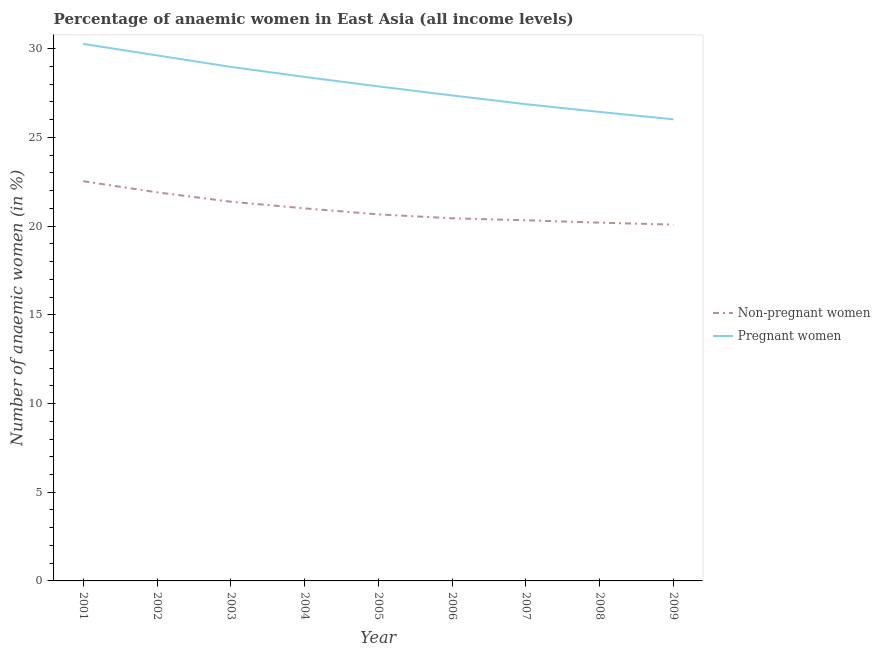Is the number of lines equal to the number of legend labels?
Give a very brief answer. Yes. What is the percentage of non-pregnant anaemic women in 2009?
Your answer should be compact. 20.09. Across all years, what is the maximum percentage of pregnant anaemic women?
Your answer should be compact. 30.27. Across all years, what is the minimum percentage of pregnant anaemic women?
Your answer should be compact. 26.02. What is the total percentage of pregnant anaemic women in the graph?
Your answer should be very brief. 251.89. What is the difference between the percentage of non-pregnant anaemic women in 2001 and that in 2002?
Your answer should be compact. 0.63. What is the difference between the percentage of non-pregnant anaemic women in 2003 and the percentage of pregnant anaemic women in 2006?
Make the answer very short. -5.99. What is the average percentage of non-pregnant anaemic women per year?
Offer a very short reply. 20.95. In the year 2009, what is the difference between the percentage of pregnant anaemic women and percentage of non-pregnant anaemic women?
Provide a succinct answer. 5.94. What is the ratio of the percentage of pregnant anaemic women in 2002 to that in 2007?
Give a very brief answer. 1.1. Is the difference between the percentage of pregnant anaemic women in 2002 and 2008 greater than the difference between the percentage of non-pregnant anaemic women in 2002 and 2008?
Your answer should be very brief. Yes. What is the difference between the highest and the second highest percentage of pregnant anaemic women?
Offer a terse response. 0.65. What is the difference between the highest and the lowest percentage of non-pregnant anaemic women?
Keep it short and to the point. 2.45. In how many years, is the percentage of non-pregnant anaemic women greater than the average percentage of non-pregnant anaemic women taken over all years?
Give a very brief answer. 4. Is the percentage of pregnant anaemic women strictly less than the percentage of non-pregnant anaemic women over the years?
Provide a succinct answer. No. Does the graph contain any zero values?
Your response must be concise. No. Does the graph contain grids?
Offer a terse response. No. Where does the legend appear in the graph?
Your answer should be very brief. Center right. How many legend labels are there?
Keep it short and to the point. 2. How are the legend labels stacked?
Offer a terse response. Vertical. What is the title of the graph?
Ensure brevity in your answer.  Percentage of anaemic women in East Asia (all income levels). What is the label or title of the X-axis?
Provide a succinct answer. Year. What is the label or title of the Y-axis?
Offer a terse response. Number of anaemic women (in %). What is the Number of anaemic women (in %) of Non-pregnant women in 2001?
Your answer should be very brief. 22.53. What is the Number of anaemic women (in %) of Pregnant women in 2001?
Ensure brevity in your answer.  30.27. What is the Number of anaemic women (in %) of Non-pregnant women in 2002?
Your answer should be compact. 21.91. What is the Number of anaemic women (in %) of Pregnant women in 2002?
Make the answer very short. 29.63. What is the Number of anaemic women (in %) in Non-pregnant women in 2003?
Your response must be concise. 21.38. What is the Number of anaemic women (in %) in Pregnant women in 2003?
Offer a very short reply. 28.98. What is the Number of anaemic women (in %) of Non-pregnant women in 2004?
Keep it short and to the point. 21. What is the Number of anaemic women (in %) in Pregnant women in 2004?
Offer a terse response. 28.41. What is the Number of anaemic women (in %) in Non-pregnant women in 2005?
Provide a succinct answer. 20.66. What is the Number of anaemic women (in %) of Pregnant women in 2005?
Offer a very short reply. 27.88. What is the Number of anaemic women (in %) in Non-pregnant women in 2006?
Make the answer very short. 20.44. What is the Number of anaemic women (in %) in Pregnant women in 2006?
Provide a short and direct response. 27.37. What is the Number of anaemic women (in %) of Non-pregnant women in 2007?
Provide a succinct answer. 20.33. What is the Number of anaemic women (in %) of Pregnant women in 2007?
Ensure brevity in your answer.  26.88. What is the Number of anaemic women (in %) of Non-pregnant women in 2008?
Your answer should be very brief. 20.2. What is the Number of anaemic women (in %) of Pregnant women in 2008?
Ensure brevity in your answer.  26.44. What is the Number of anaemic women (in %) in Non-pregnant women in 2009?
Make the answer very short. 20.09. What is the Number of anaemic women (in %) in Pregnant women in 2009?
Offer a very short reply. 26.02. Across all years, what is the maximum Number of anaemic women (in %) in Non-pregnant women?
Make the answer very short. 22.53. Across all years, what is the maximum Number of anaemic women (in %) in Pregnant women?
Offer a very short reply. 30.27. Across all years, what is the minimum Number of anaemic women (in %) in Non-pregnant women?
Provide a short and direct response. 20.09. Across all years, what is the minimum Number of anaemic women (in %) in Pregnant women?
Your answer should be compact. 26.02. What is the total Number of anaemic women (in %) in Non-pregnant women in the graph?
Your response must be concise. 188.55. What is the total Number of anaemic women (in %) in Pregnant women in the graph?
Your answer should be very brief. 251.89. What is the difference between the Number of anaemic women (in %) in Non-pregnant women in 2001 and that in 2002?
Your answer should be very brief. 0.63. What is the difference between the Number of anaemic women (in %) in Pregnant women in 2001 and that in 2002?
Your response must be concise. 0.65. What is the difference between the Number of anaemic women (in %) of Non-pregnant women in 2001 and that in 2003?
Make the answer very short. 1.15. What is the difference between the Number of anaemic women (in %) of Pregnant women in 2001 and that in 2003?
Make the answer very short. 1.29. What is the difference between the Number of anaemic women (in %) in Non-pregnant women in 2001 and that in 2004?
Give a very brief answer. 1.53. What is the difference between the Number of anaemic women (in %) of Pregnant women in 2001 and that in 2004?
Provide a succinct answer. 1.86. What is the difference between the Number of anaemic women (in %) of Non-pregnant women in 2001 and that in 2005?
Give a very brief answer. 1.87. What is the difference between the Number of anaemic women (in %) of Pregnant women in 2001 and that in 2005?
Provide a short and direct response. 2.4. What is the difference between the Number of anaemic women (in %) of Non-pregnant women in 2001 and that in 2006?
Your answer should be compact. 2.09. What is the difference between the Number of anaemic women (in %) in Pregnant women in 2001 and that in 2006?
Ensure brevity in your answer.  2.9. What is the difference between the Number of anaemic women (in %) of Non-pregnant women in 2001 and that in 2007?
Your answer should be compact. 2.2. What is the difference between the Number of anaemic women (in %) of Pregnant women in 2001 and that in 2007?
Make the answer very short. 3.4. What is the difference between the Number of anaemic women (in %) of Non-pregnant women in 2001 and that in 2008?
Offer a terse response. 2.34. What is the difference between the Number of anaemic women (in %) of Pregnant women in 2001 and that in 2008?
Your answer should be very brief. 3.83. What is the difference between the Number of anaemic women (in %) of Non-pregnant women in 2001 and that in 2009?
Provide a succinct answer. 2.45. What is the difference between the Number of anaemic women (in %) in Pregnant women in 2001 and that in 2009?
Offer a very short reply. 4.25. What is the difference between the Number of anaemic women (in %) of Non-pregnant women in 2002 and that in 2003?
Make the answer very short. 0.53. What is the difference between the Number of anaemic women (in %) in Pregnant women in 2002 and that in 2003?
Ensure brevity in your answer.  0.65. What is the difference between the Number of anaemic women (in %) of Non-pregnant women in 2002 and that in 2004?
Your answer should be very brief. 0.9. What is the difference between the Number of anaemic women (in %) in Pregnant women in 2002 and that in 2004?
Provide a short and direct response. 1.21. What is the difference between the Number of anaemic women (in %) in Non-pregnant women in 2002 and that in 2005?
Ensure brevity in your answer.  1.24. What is the difference between the Number of anaemic women (in %) of Pregnant women in 2002 and that in 2005?
Offer a terse response. 1.75. What is the difference between the Number of anaemic women (in %) of Non-pregnant women in 2002 and that in 2006?
Provide a succinct answer. 1.46. What is the difference between the Number of anaemic women (in %) of Pregnant women in 2002 and that in 2006?
Make the answer very short. 2.26. What is the difference between the Number of anaemic women (in %) of Non-pregnant women in 2002 and that in 2007?
Provide a short and direct response. 1.58. What is the difference between the Number of anaemic women (in %) in Pregnant women in 2002 and that in 2007?
Give a very brief answer. 2.75. What is the difference between the Number of anaemic women (in %) in Non-pregnant women in 2002 and that in 2008?
Your answer should be compact. 1.71. What is the difference between the Number of anaemic women (in %) of Pregnant women in 2002 and that in 2008?
Keep it short and to the point. 3.19. What is the difference between the Number of anaemic women (in %) in Non-pregnant women in 2002 and that in 2009?
Provide a succinct answer. 1.82. What is the difference between the Number of anaemic women (in %) of Pregnant women in 2002 and that in 2009?
Make the answer very short. 3.6. What is the difference between the Number of anaemic women (in %) of Non-pregnant women in 2003 and that in 2004?
Your response must be concise. 0.37. What is the difference between the Number of anaemic women (in %) in Pregnant women in 2003 and that in 2004?
Ensure brevity in your answer.  0.57. What is the difference between the Number of anaemic women (in %) in Non-pregnant women in 2003 and that in 2005?
Make the answer very short. 0.72. What is the difference between the Number of anaemic women (in %) of Pregnant women in 2003 and that in 2005?
Ensure brevity in your answer.  1.1. What is the difference between the Number of anaemic women (in %) of Non-pregnant women in 2003 and that in 2006?
Ensure brevity in your answer.  0.94. What is the difference between the Number of anaemic women (in %) of Pregnant women in 2003 and that in 2006?
Make the answer very short. 1.61. What is the difference between the Number of anaemic women (in %) in Non-pregnant women in 2003 and that in 2007?
Ensure brevity in your answer.  1.05. What is the difference between the Number of anaemic women (in %) in Pregnant women in 2003 and that in 2007?
Give a very brief answer. 2.1. What is the difference between the Number of anaemic women (in %) of Non-pregnant women in 2003 and that in 2008?
Your answer should be compact. 1.18. What is the difference between the Number of anaemic women (in %) in Pregnant women in 2003 and that in 2008?
Ensure brevity in your answer.  2.54. What is the difference between the Number of anaemic women (in %) of Non-pregnant women in 2003 and that in 2009?
Ensure brevity in your answer.  1.29. What is the difference between the Number of anaemic women (in %) in Pregnant women in 2003 and that in 2009?
Offer a very short reply. 2.96. What is the difference between the Number of anaemic women (in %) in Non-pregnant women in 2004 and that in 2005?
Provide a succinct answer. 0.34. What is the difference between the Number of anaemic women (in %) of Pregnant women in 2004 and that in 2005?
Your answer should be compact. 0.53. What is the difference between the Number of anaemic women (in %) in Non-pregnant women in 2004 and that in 2006?
Your response must be concise. 0.56. What is the difference between the Number of anaemic women (in %) of Pregnant women in 2004 and that in 2006?
Your answer should be very brief. 1.04. What is the difference between the Number of anaemic women (in %) of Non-pregnant women in 2004 and that in 2007?
Your answer should be very brief. 0.67. What is the difference between the Number of anaemic women (in %) of Pregnant women in 2004 and that in 2007?
Provide a short and direct response. 1.54. What is the difference between the Number of anaemic women (in %) in Non-pregnant women in 2004 and that in 2008?
Your response must be concise. 0.81. What is the difference between the Number of anaemic women (in %) of Pregnant women in 2004 and that in 2008?
Offer a very short reply. 1.97. What is the difference between the Number of anaemic women (in %) in Non-pregnant women in 2004 and that in 2009?
Your answer should be compact. 0.92. What is the difference between the Number of anaemic women (in %) in Pregnant women in 2004 and that in 2009?
Keep it short and to the point. 2.39. What is the difference between the Number of anaemic women (in %) of Non-pregnant women in 2005 and that in 2006?
Keep it short and to the point. 0.22. What is the difference between the Number of anaemic women (in %) of Pregnant women in 2005 and that in 2006?
Make the answer very short. 0.51. What is the difference between the Number of anaemic women (in %) of Non-pregnant women in 2005 and that in 2007?
Give a very brief answer. 0.33. What is the difference between the Number of anaemic women (in %) in Pregnant women in 2005 and that in 2007?
Your answer should be very brief. 1. What is the difference between the Number of anaemic women (in %) in Non-pregnant women in 2005 and that in 2008?
Make the answer very short. 0.47. What is the difference between the Number of anaemic women (in %) in Pregnant women in 2005 and that in 2008?
Provide a short and direct response. 1.44. What is the difference between the Number of anaemic women (in %) in Non-pregnant women in 2005 and that in 2009?
Keep it short and to the point. 0.58. What is the difference between the Number of anaemic women (in %) of Pregnant women in 2005 and that in 2009?
Provide a short and direct response. 1.86. What is the difference between the Number of anaemic women (in %) of Non-pregnant women in 2006 and that in 2007?
Your response must be concise. 0.11. What is the difference between the Number of anaemic women (in %) in Pregnant women in 2006 and that in 2007?
Keep it short and to the point. 0.49. What is the difference between the Number of anaemic women (in %) in Non-pregnant women in 2006 and that in 2008?
Offer a terse response. 0.25. What is the difference between the Number of anaemic women (in %) in Pregnant women in 2006 and that in 2008?
Your answer should be compact. 0.93. What is the difference between the Number of anaemic women (in %) of Non-pregnant women in 2006 and that in 2009?
Provide a succinct answer. 0.36. What is the difference between the Number of anaemic women (in %) of Pregnant women in 2006 and that in 2009?
Your response must be concise. 1.35. What is the difference between the Number of anaemic women (in %) of Non-pregnant women in 2007 and that in 2008?
Your response must be concise. 0.13. What is the difference between the Number of anaemic women (in %) of Pregnant women in 2007 and that in 2008?
Provide a short and direct response. 0.44. What is the difference between the Number of anaemic women (in %) of Non-pregnant women in 2007 and that in 2009?
Give a very brief answer. 0.24. What is the difference between the Number of anaemic women (in %) of Pregnant women in 2007 and that in 2009?
Your answer should be very brief. 0.85. What is the difference between the Number of anaemic women (in %) of Non-pregnant women in 2008 and that in 2009?
Offer a terse response. 0.11. What is the difference between the Number of anaemic women (in %) of Pregnant women in 2008 and that in 2009?
Offer a very short reply. 0.42. What is the difference between the Number of anaemic women (in %) in Non-pregnant women in 2001 and the Number of anaemic women (in %) in Pregnant women in 2002?
Ensure brevity in your answer.  -7.09. What is the difference between the Number of anaemic women (in %) of Non-pregnant women in 2001 and the Number of anaemic women (in %) of Pregnant women in 2003?
Your response must be concise. -6.45. What is the difference between the Number of anaemic women (in %) in Non-pregnant women in 2001 and the Number of anaemic women (in %) in Pregnant women in 2004?
Provide a short and direct response. -5.88. What is the difference between the Number of anaemic women (in %) in Non-pregnant women in 2001 and the Number of anaemic women (in %) in Pregnant women in 2005?
Give a very brief answer. -5.35. What is the difference between the Number of anaemic women (in %) of Non-pregnant women in 2001 and the Number of anaemic women (in %) of Pregnant women in 2006?
Your answer should be compact. -4.84. What is the difference between the Number of anaemic women (in %) of Non-pregnant women in 2001 and the Number of anaemic women (in %) of Pregnant women in 2007?
Offer a very short reply. -4.34. What is the difference between the Number of anaemic women (in %) in Non-pregnant women in 2001 and the Number of anaemic women (in %) in Pregnant women in 2008?
Your answer should be compact. -3.91. What is the difference between the Number of anaemic women (in %) of Non-pregnant women in 2001 and the Number of anaemic women (in %) of Pregnant women in 2009?
Your response must be concise. -3.49. What is the difference between the Number of anaemic women (in %) in Non-pregnant women in 2002 and the Number of anaemic women (in %) in Pregnant women in 2003?
Offer a very short reply. -7.07. What is the difference between the Number of anaemic women (in %) of Non-pregnant women in 2002 and the Number of anaemic women (in %) of Pregnant women in 2004?
Give a very brief answer. -6.51. What is the difference between the Number of anaemic women (in %) of Non-pregnant women in 2002 and the Number of anaemic women (in %) of Pregnant women in 2005?
Your answer should be very brief. -5.97. What is the difference between the Number of anaemic women (in %) of Non-pregnant women in 2002 and the Number of anaemic women (in %) of Pregnant women in 2006?
Ensure brevity in your answer.  -5.46. What is the difference between the Number of anaemic women (in %) of Non-pregnant women in 2002 and the Number of anaemic women (in %) of Pregnant women in 2007?
Provide a short and direct response. -4.97. What is the difference between the Number of anaemic women (in %) of Non-pregnant women in 2002 and the Number of anaemic women (in %) of Pregnant women in 2008?
Keep it short and to the point. -4.53. What is the difference between the Number of anaemic women (in %) in Non-pregnant women in 2002 and the Number of anaemic women (in %) in Pregnant women in 2009?
Ensure brevity in your answer.  -4.12. What is the difference between the Number of anaemic women (in %) in Non-pregnant women in 2003 and the Number of anaemic women (in %) in Pregnant women in 2004?
Offer a very short reply. -7.03. What is the difference between the Number of anaemic women (in %) in Non-pregnant women in 2003 and the Number of anaemic women (in %) in Pregnant women in 2005?
Your answer should be very brief. -6.5. What is the difference between the Number of anaemic women (in %) in Non-pregnant women in 2003 and the Number of anaemic women (in %) in Pregnant women in 2006?
Provide a short and direct response. -5.99. What is the difference between the Number of anaemic women (in %) in Non-pregnant women in 2003 and the Number of anaemic women (in %) in Pregnant women in 2007?
Provide a succinct answer. -5.5. What is the difference between the Number of anaemic women (in %) in Non-pregnant women in 2003 and the Number of anaemic women (in %) in Pregnant women in 2008?
Give a very brief answer. -5.06. What is the difference between the Number of anaemic women (in %) of Non-pregnant women in 2003 and the Number of anaemic women (in %) of Pregnant women in 2009?
Provide a short and direct response. -4.64. What is the difference between the Number of anaemic women (in %) in Non-pregnant women in 2004 and the Number of anaemic women (in %) in Pregnant women in 2005?
Your response must be concise. -6.87. What is the difference between the Number of anaemic women (in %) of Non-pregnant women in 2004 and the Number of anaemic women (in %) of Pregnant women in 2006?
Offer a terse response. -6.37. What is the difference between the Number of anaemic women (in %) in Non-pregnant women in 2004 and the Number of anaemic women (in %) in Pregnant women in 2007?
Your answer should be very brief. -5.87. What is the difference between the Number of anaemic women (in %) of Non-pregnant women in 2004 and the Number of anaemic women (in %) of Pregnant women in 2008?
Your answer should be compact. -5.44. What is the difference between the Number of anaemic women (in %) in Non-pregnant women in 2004 and the Number of anaemic women (in %) in Pregnant women in 2009?
Your response must be concise. -5.02. What is the difference between the Number of anaemic women (in %) of Non-pregnant women in 2005 and the Number of anaemic women (in %) of Pregnant women in 2006?
Keep it short and to the point. -6.71. What is the difference between the Number of anaemic women (in %) in Non-pregnant women in 2005 and the Number of anaemic women (in %) in Pregnant women in 2007?
Give a very brief answer. -6.21. What is the difference between the Number of anaemic women (in %) in Non-pregnant women in 2005 and the Number of anaemic women (in %) in Pregnant women in 2008?
Your response must be concise. -5.78. What is the difference between the Number of anaemic women (in %) in Non-pregnant women in 2005 and the Number of anaemic women (in %) in Pregnant women in 2009?
Your response must be concise. -5.36. What is the difference between the Number of anaemic women (in %) of Non-pregnant women in 2006 and the Number of anaemic women (in %) of Pregnant women in 2007?
Make the answer very short. -6.43. What is the difference between the Number of anaemic women (in %) of Non-pregnant women in 2006 and the Number of anaemic women (in %) of Pregnant women in 2008?
Give a very brief answer. -6. What is the difference between the Number of anaemic women (in %) in Non-pregnant women in 2006 and the Number of anaemic women (in %) in Pregnant women in 2009?
Provide a succinct answer. -5.58. What is the difference between the Number of anaemic women (in %) in Non-pregnant women in 2007 and the Number of anaemic women (in %) in Pregnant women in 2008?
Give a very brief answer. -6.11. What is the difference between the Number of anaemic women (in %) in Non-pregnant women in 2007 and the Number of anaemic women (in %) in Pregnant women in 2009?
Your answer should be very brief. -5.69. What is the difference between the Number of anaemic women (in %) in Non-pregnant women in 2008 and the Number of anaemic women (in %) in Pregnant women in 2009?
Your answer should be very brief. -5.83. What is the average Number of anaemic women (in %) in Non-pregnant women per year?
Keep it short and to the point. 20.95. What is the average Number of anaemic women (in %) of Pregnant women per year?
Your answer should be compact. 27.99. In the year 2001, what is the difference between the Number of anaemic women (in %) in Non-pregnant women and Number of anaemic women (in %) in Pregnant women?
Give a very brief answer. -7.74. In the year 2002, what is the difference between the Number of anaemic women (in %) in Non-pregnant women and Number of anaemic women (in %) in Pregnant women?
Your answer should be compact. -7.72. In the year 2003, what is the difference between the Number of anaemic women (in %) of Non-pregnant women and Number of anaemic women (in %) of Pregnant women?
Offer a terse response. -7.6. In the year 2004, what is the difference between the Number of anaemic women (in %) in Non-pregnant women and Number of anaemic women (in %) in Pregnant women?
Give a very brief answer. -7.41. In the year 2005, what is the difference between the Number of anaemic women (in %) in Non-pregnant women and Number of anaemic women (in %) in Pregnant women?
Offer a terse response. -7.22. In the year 2006, what is the difference between the Number of anaemic women (in %) in Non-pregnant women and Number of anaemic women (in %) in Pregnant women?
Your answer should be very brief. -6.93. In the year 2007, what is the difference between the Number of anaemic women (in %) of Non-pregnant women and Number of anaemic women (in %) of Pregnant women?
Give a very brief answer. -6.55. In the year 2008, what is the difference between the Number of anaemic women (in %) of Non-pregnant women and Number of anaemic women (in %) of Pregnant women?
Offer a very short reply. -6.24. In the year 2009, what is the difference between the Number of anaemic women (in %) in Non-pregnant women and Number of anaemic women (in %) in Pregnant women?
Offer a very short reply. -5.94. What is the ratio of the Number of anaemic women (in %) of Non-pregnant women in 2001 to that in 2002?
Provide a short and direct response. 1.03. What is the ratio of the Number of anaemic women (in %) of Pregnant women in 2001 to that in 2002?
Provide a short and direct response. 1.02. What is the ratio of the Number of anaemic women (in %) of Non-pregnant women in 2001 to that in 2003?
Your response must be concise. 1.05. What is the ratio of the Number of anaemic women (in %) of Pregnant women in 2001 to that in 2003?
Provide a succinct answer. 1.04. What is the ratio of the Number of anaemic women (in %) in Non-pregnant women in 2001 to that in 2004?
Provide a short and direct response. 1.07. What is the ratio of the Number of anaemic women (in %) of Pregnant women in 2001 to that in 2004?
Offer a very short reply. 1.07. What is the ratio of the Number of anaemic women (in %) of Non-pregnant women in 2001 to that in 2005?
Make the answer very short. 1.09. What is the ratio of the Number of anaemic women (in %) in Pregnant women in 2001 to that in 2005?
Your answer should be very brief. 1.09. What is the ratio of the Number of anaemic women (in %) in Non-pregnant women in 2001 to that in 2006?
Provide a succinct answer. 1.1. What is the ratio of the Number of anaemic women (in %) in Pregnant women in 2001 to that in 2006?
Give a very brief answer. 1.11. What is the ratio of the Number of anaemic women (in %) of Non-pregnant women in 2001 to that in 2007?
Make the answer very short. 1.11. What is the ratio of the Number of anaemic women (in %) in Pregnant women in 2001 to that in 2007?
Keep it short and to the point. 1.13. What is the ratio of the Number of anaemic women (in %) in Non-pregnant women in 2001 to that in 2008?
Offer a very short reply. 1.12. What is the ratio of the Number of anaemic women (in %) of Pregnant women in 2001 to that in 2008?
Your answer should be compact. 1.15. What is the ratio of the Number of anaemic women (in %) of Non-pregnant women in 2001 to that in 2009?
Make the answer very short. 1.12. What is the ratio of the Number of anaemic women (in %) in Pregnant women in 2001 to that in 2009?
Give a very brief answer. 1.16. What is the ratio of the Number of anaemic women (in %) in Non-pregnant women in 2002 to that in 2003?
Provide a succinct answer. 1.02. What is the ratio of the Number of anaemic women (in %) in Pregnant women in 2002 to that in 2003?
Your answer should be compact. 1.02. What is the ratio of the Number of anaemic women (in %) in Non-pregnant women in 2002 to that in 2004?
Keep it short and to the point. 1.04. What is the ratio of the Number of anaemic women (in %) in Pregnant women in 2002 to that in 2004?
Offer a very short reply. 1.04. What is the ratio of the Number of anaemic women (in %) in Non-pregnant women in 2002 to that in 2005?
Keep it short and to the point. 1.06. What is the ratio of the Number of anaemic women (in %) of Pregnant women in 2002 to that in 2005?
Provide a succinct answer. 1.06. What is the ratio of the Number of anaemic women (in %) of Non-pregnant women in 2002 to that in 2006?
Give a very brief answer. 1.07. What is the ratio of the Number of anaemic women (in %) in Pregnant women in 2002 to that in 2006?
Provide a succinct answer. 1.08. What is the ratio of the Number of anaemic women (in %) in Non-pregnant women in 2002 to that in 2007?
Give a very brief answer. 1.08. What is the ratio of the Number of anaemic women (in %) in Pregnant women in 2002 to that in 2007?
Make the answer very short. 1.1. What is the ratio of the Number of anaemic women (in %) in Non-pregnant women in 2002 to that in 2008?
Provide a succinct answer. 1.08. What is the ratio of the Number of anaemic women (in %) in Pregnant women in 2002 to that in 2008?
Keep it short and to the point. 1.12. What is the ratio of the Number of anaemic women (in %) of Non-pregnant women in 2002 to that in 2009?
Provide a succinct answer. 1.09. What is the ratio of the Number of anaemic women (in %) of Pregnant women in 2002 to that in 2009?
Your response must be concise. 1.14. What is the ratio of the Number of anaemic women (in %) in Non-pregnant women in 2003 to that in 2004?
Provide a short and direct response. 1.02. What is the ratio of the Number of anaemic women (in %) in Pregnant women in 2003 to that in 2004?
Your response must be concise. 1.02. What is the ratio of the Number of anaemic women (in %) of Non-pregnant women in 2003 to that in 2005?
Ensure brevity in your answer.  1.03. What is the ratio of the Number of anaemic women (in %) in Pregnant women in 2003 to that in 2005?
Provide a short and direct response. 1.04. What is the ratio of the Number of anaemic women (in %) in Non-pregnant women in 2003 to that in 2006?
Your answer should be very brief. 1.05. What is the ratio of the Number of anaemic women (in %) of Pregnant women in 2003 to that in 2006?
Provide a succinct answer. 1.06. What is the ratio of the Number of anaemic women (in %) in Non-pregnant women in 2003 to that in 2007?
Give a very brief answer. 1.05. What is the ratio of the Number of anaemic women (in %) of Pregnant women in 2003 to that in 2007?
Give a very brief answer. 1.08. What is the ratio of the Number of anaemic women (in %) in Non-pregnant women in 2003 to that in 2008?
Keep it short and to the point. 1.06. What is the ratio of the Number of anaemic women (in %) of Pregnant women in 2003 to that in 2008?
Provide a succinct answer. 1.1. What is the ratio of the Number of anaemic women (in %) of Non-pregnant women in 2003 to that in 2009?
Keep it short and to the point. 1.06. What is the ratio of the Number of anaemic women (in %) of Pregnant women in 2003 to that in 2009?
Give a very brief answer. 1.11. What is the ratio of the Number of anaemic women (in %) of Non-pregnant women in 2004 to that in 2005?
Offer a very short reply. 1.02. What is the ratio of the Number of anaemic women (in %) in Pregnant women in 2004 to that in 2005?
Provide a short and direct response. 1.02. What is the ratio of the Number of anaemic women (in %) of Non-pregnant women in 2004 to that in 2006?
Provide a short and direct response. 1.03. What is the ratio of the Number of anaemic women (in %) of Pregnant women in 2004 to that in 2006?
Make the answer very short. 1.04. What is the ratio of the Number of anaemic women (in %) of Non-pregnant women in 2004 to that in 2007?
Make the answer very short. 1.03. What is the ratio of the Number of anaemic women (in %) in Pregnant women in 2004 to that in 2007?
Provide a succinct answer. 1.06. What is the ratio of the Number of anaemic women (in %) in Non-pregnant women in 2004 to that in 2008?
Ensure brevity in your answer.  1.04. What is the ratio of the Number of anaemic women (in %) in Pregnant women in 2004 to that in 2008?
Give a very brief answer. 1.07. What is the ratio of the Number of anaemic women (in %) of Non-pregnant women in 2004 to that in 2009?
Provide a succinct answer. 1.05. What is the ratio of the Number of anaemic women (in %) of Pregnant women in 2004 to that in 2009?
Ensure brevity in your answer.  1.09. What is the ratio of the Number of anaemic women (in %) of Non-pregnant women in 2005 to that in 2006?
Ensure brevity in your answer.  1.01. What is the ratio of the Number of anaemic women (in %) of Pregnant women in 2005 to that in 2006?
Your answer should be very brief. 1.02. What is the ratio of the Number of anaemic women (in %) in Non-pregnant women in 2005 to that in 2007?
Provide a succinct answer. 1.02. What is the ratio of the Number of anaemic women (in %) in Pregnant women in 2005 to that in 2007?
Provide a succinct answer. 1.04. What is the ratio of the Number of anaemic women (in %) of Non-pregnant women in 2005 to that in 2008?
Your answer should be very brief. 1.02. What is the ratio of the Number of anaemic women (in %) in Pregnant women in 2005 to that in 2008?
Provide a succinct answer. 1.05. What is the ratio of the Number of anaemic women (in %) of Non-pregnant women in 2005 to that in 2009?
Your answer should be compact. 1.03. What is the ratio of the Number of anaemic women (in %) of Pregnant women in 2005 to that in 2009?
Your answer should be very brief. 1.07. What is the ratio of the Number of anaemic women (in %) of Non-pregnant women in 2006 to that in 2007?
Ensure brevity in your answer.  1.01. What is the ratio of the Number of anaemic women (in %) of Pregnant women in 2006 to that in 2007?
Give a very brief answer. 1.02. What is the ratio of the Number of anaemic women (in %) in Non-pregnant women in 2006 to that in 2008?
Make the answer very short. 1.01. What is the ratio of the Number of anaemic women (in %) in Pregnant women in 2006 to that in 2008?
Your answer should be compact. 1.04. What is the ratio of the Number of anaemic women (in %) in Non-pregnant women in 2006 to that in 2009?
Give a very brief answer. 1.02. What is the ratio of the Number of anaemic women (in %) in Pregnant women in 2006 to that in 2009?
Give a very brief answer. 1.05. What is the ratio of the Number of anaemic women (in %) in Non-pregnant women in 2007 to that in 2008?
Offer a very short reply. 1.01. What is the ratio of the Number of anaemic women (in %) of Pregnant women in 2007 to that in 2008?
Offer a very short reply. 1.02. What is the ratio of the Number of anaemic women (in %) in Non-pregnant women in 2007 to that in 2009?
Keep it short and to the point. 1.01. What is the ratio of the Number of anaemic women (in %) of Pregnant women in 2007 to that in 2009?
Keep it short and to the point. 1.03. What is the ratio of the Number of anaemic women (in %) in Non-pregnant women in 2008 to that in 2009?
Keep it short and to the point. 1.01. What is the ratio of the Number of anaemic women (in %) in Pregnant women in 2008 to that in 2009?
Keep it short and to the point. 1.02. What is the difference between the highest and the second highest Number of anaemic women (in %) in Non-pregnant women?
Make the answer very short. 0.63. What is the difference between the highest and the second highest Number of anaemic women (in %) of Pregnant women?
Give a very brief answer. 0.65. What is the difference between the highest and the lowest Number of anaemic women (in %) in Non-pregnant women?
Ensure brevity in your answer.  2.45. What is the difference between the highest and the lowest Number of anaemic women (in %) of Pregnant women?
Provide a succinct answer. 4.25. 